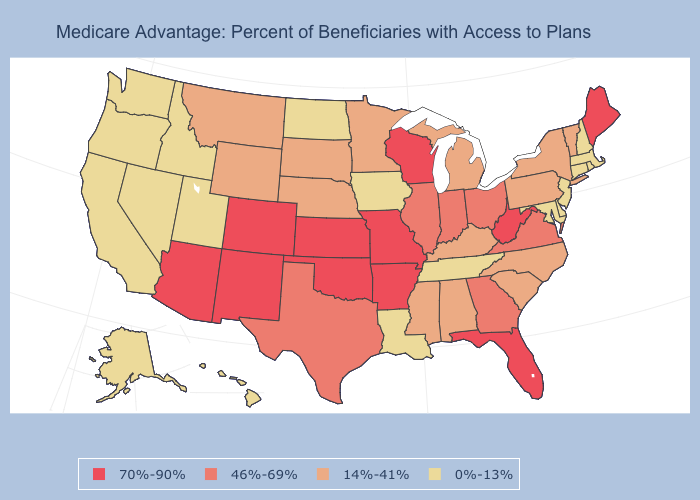What is the lowest value in the USA?
Give a very brief answer. 0%-13%. What is the value of Oklahoma?
Be succinct. 70%-90%. Does the map have missing data?
Write a very short answer. No. Name the states that have a value in the range 14%-41%?
Concise answer only. Alabama, Kentucky, Michigan, Minnesota, Mississippi, Montana, Nebraska, New York, North Carolina, Pennsylvania, South Carolina, South Dakota, Vermont, Wyoming. What is the lowest value in the West?
Keep it brief. 0%-13%. Name the states that have a value in the range 46%-69%?
Write a very short answer. Georgia, Illinois, Indiana, Ohio, Texas, Virginia. What is the lowest value in the USA?
Quick response, please. 0%-13%. What is the value of Illinois?
Quick response, please. 46%-69%. Does Missouri have the highest value in the MidWest?
Keep it brief. Yes. Name the states that have a value in the range 0%-13%?
Quick response, please. Alaska, California, Connecticut, Delaware, Hawaii, Idaho, Iowa, Louisiana, Maryland, Massachusetts, Nevada, New Hampshire, New Jersey, North Dakota, Oregon, Rhode Island, Tennessee, Utah, Washington. What is the value of New Hampshire?
Short answer required. 0%-13%. Among the states that border Michigan , does Indiana have the highest value?
Quick response, please. No. Does the map have missing data?
Quick response, please. No. Name the states that have a value in the range 0%-13%?
Write a very short answer. Alaska, California, Connecticut, Delaware, Hawaii, Idaho, Iowa, Louisiana, Maryland, Massachusetts, Nevada, New Hampshire, New Jersey, North Dakota, Oregon, Rhode Island, Tennessee, Utah, Washington. Is the legend a continuous bar?
Short answer required. No. 